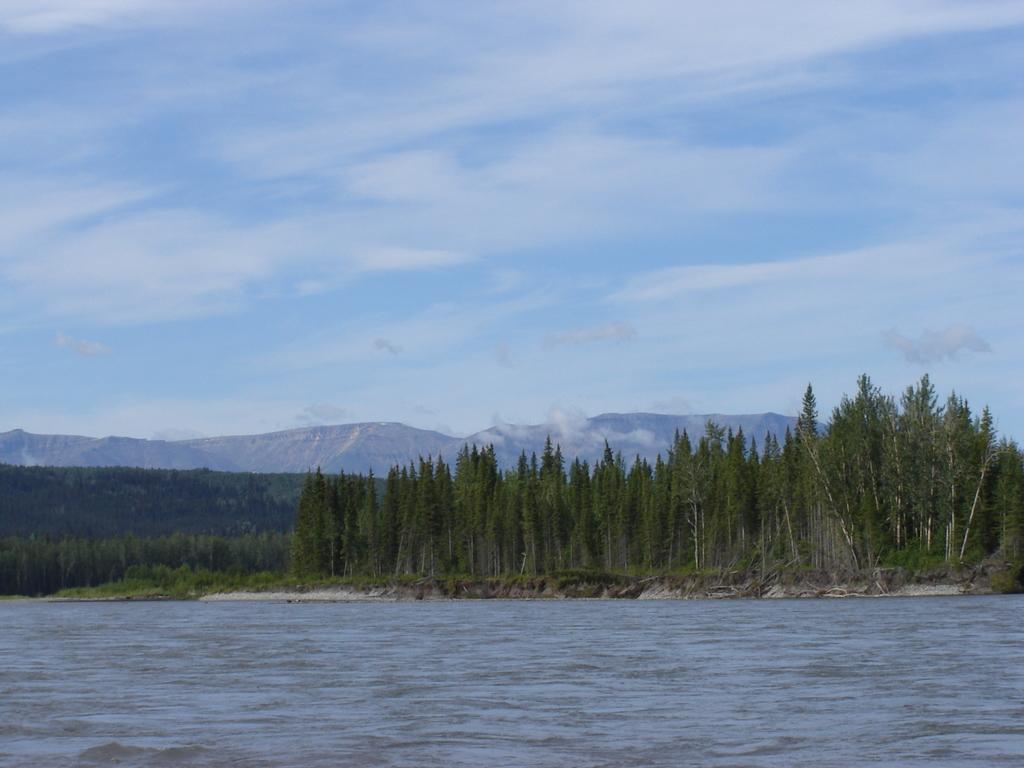What type of natural elements can be seen in the image? There are trees and water visible in the image. What geographical feature is present in the image? There is a mountain in the image. What is the condition of the sky in the image? The sky is cloudy in the image. What type of sweater is being worn by the mountain in the image? There are no people or clothing items present in the image, as it features natural elements such as trees, water, and a mountain. 